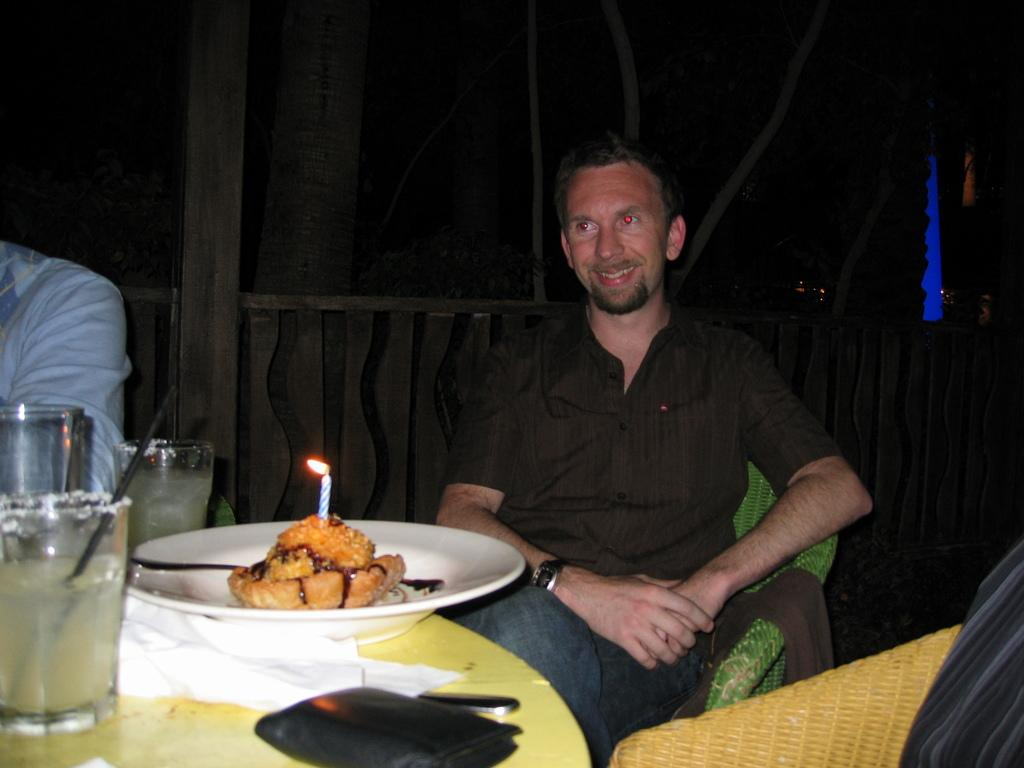What is the person in the image doing? The person is sitting on a chair in the image. What is located in front of the person? The person is in front of a table. What can be seen on the table? There is a plate with a food item and a glass on the table. Are there any other objects on the table? Yes, there is a wallet on the table. What type of comb is being used to stir the food on the plate? There is no comb present in the image, and the food on the plate is not being stirred. 